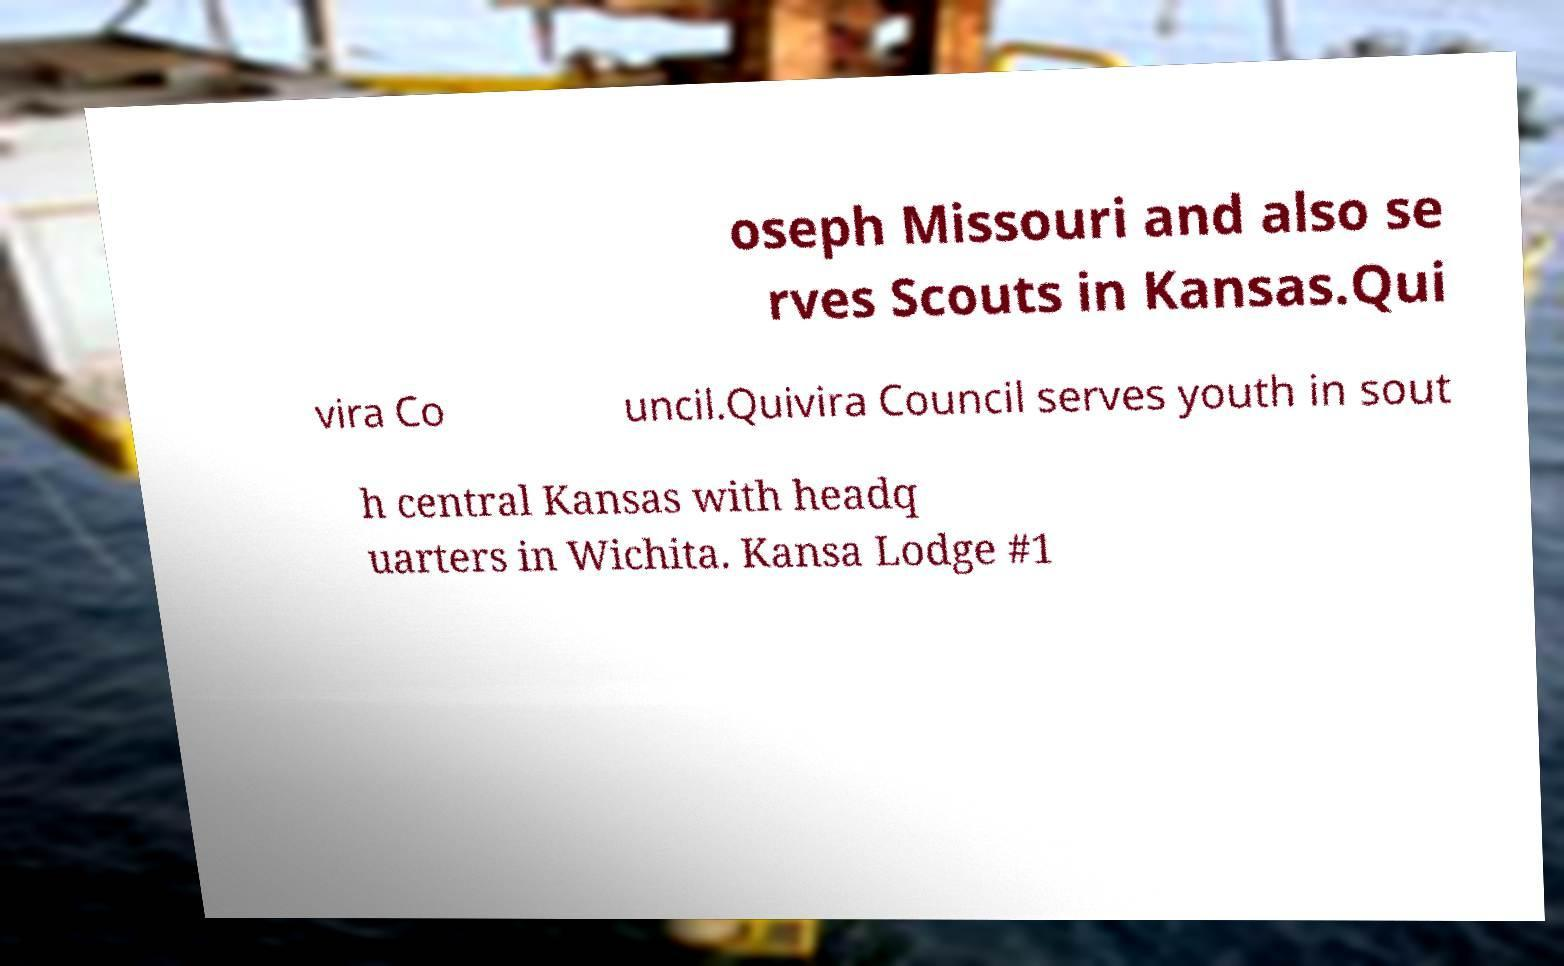There's text embedded in this image that I need extracted. Can you transcribe it verbatim? oseph Missouri and also se rves Scouts in Kansas.Qui vira Co uncil.Quivira Council serves youth in sout h central Kansas with headq uarters in Wichita. Kansa Lodge #1 